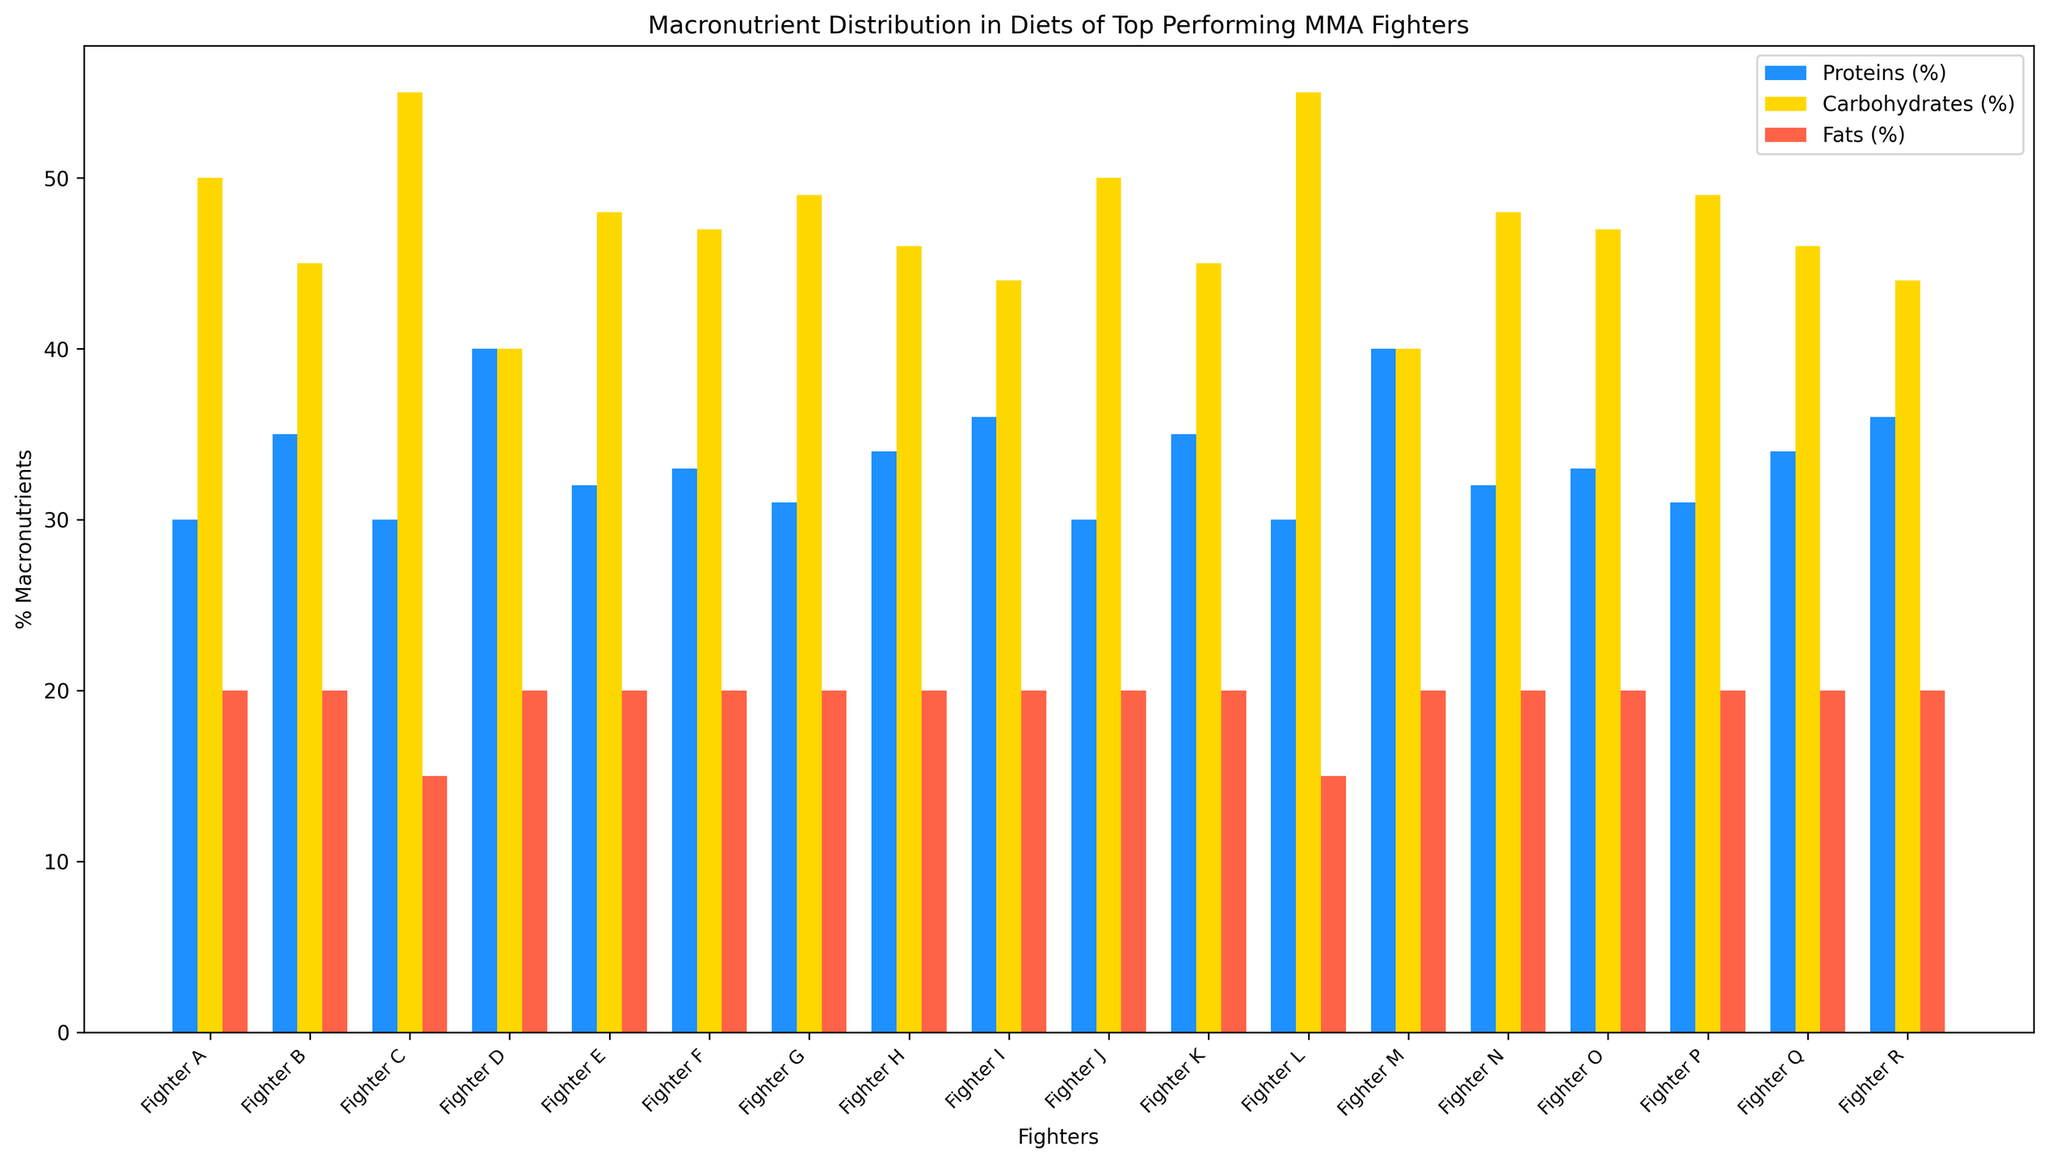What is the highest percentage of proteins among the fighters? By looking at the bar for proteins (blue bars), the highest percentage appears to be Fighter D and Fighter M, both at 40%.
Answer: 40% Which fighter has the lowest percentage of fats in their diet? The lowest percentage of fats (red bars) is 15%, which corresponds to Fighter C and Fighter L.
Answer: Fighter C and Fighter L What is the combined percentage of carbohydrates and fats for Fighter A? Fighter A has 50% carbohydrates and 20% fats. Combined, this is 50% + 20% = 70%.
Answer: 70% How many fighters have the same percentage (20%) of fats in their diets? All red bars representing fats that are at 20% correspond to this question. There are 15 fighters with 20% fats.
Answer: 15 Which fighter has an equal percentage of carbohydrates and proteins? The fighter with equal blue and yellow bars are Fighter D and Fighter M with 40% for both carbohydrates and proteins.
Answer: Fighter D and Fighter M What is the average protein intake (%) across all fighters? Summing the protein percentages (30+35+30+40+32+33+31+34+36+30+35+30+40+32+33+31+34+36) gives 564%. Dividing by 18 fighters: 564 ÷ 18 ≈ 31.33%.
Answer: 31.33% Between Fighter F and Fighter G, who has a higher percentage of carbohydrates? Fighter F has 47% carbohydrates, while Fighter G has 49%. Therefore, Fighter G has a higher percentage.
Answer: Fighter G If a new fighter is added with 35% proteins, 50% carbohydrates, and 15% fats, will the average fat percentage across fighters change? If so, by how much? Current total fat percentage: 315%. With the new fighter, total becomes 315% + 15% = 330%. Average for 19 fighters: 330 ÷ 19 ≈ 17.37%. The current average is 315 ÷ 18 ≈ 17.5%. Change is 17.5% - 17.37% ≈ 0.13%.
Answer: 0.13% Which fighter has the widest distribution between their highest and lowest macronutrient percentage? Distribution difference calculation for each fighter reveals Fighter C and L with the widest difference (55% - 15% = 40%) between carbohydrates and fats.
Answer: Fighter C and Fighter L 